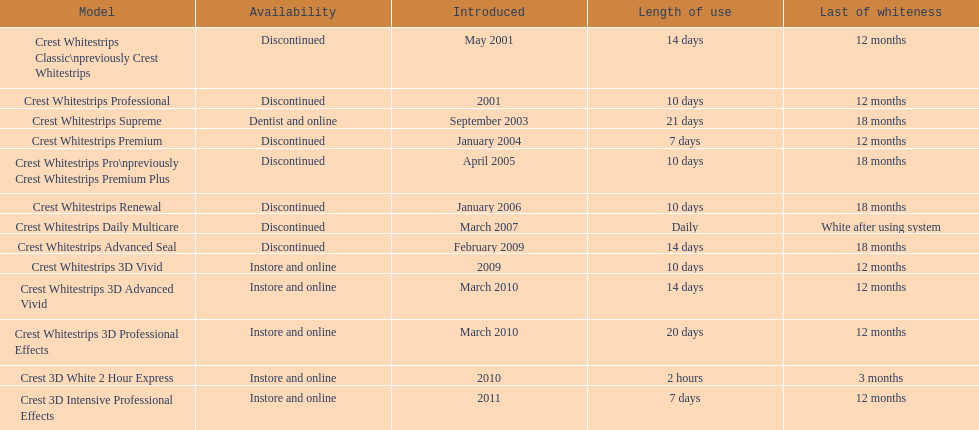Which item was launched in the same month as crest whitestrips 3d advanced vivid? Crest Whitestrips 3D Professional Effects. 